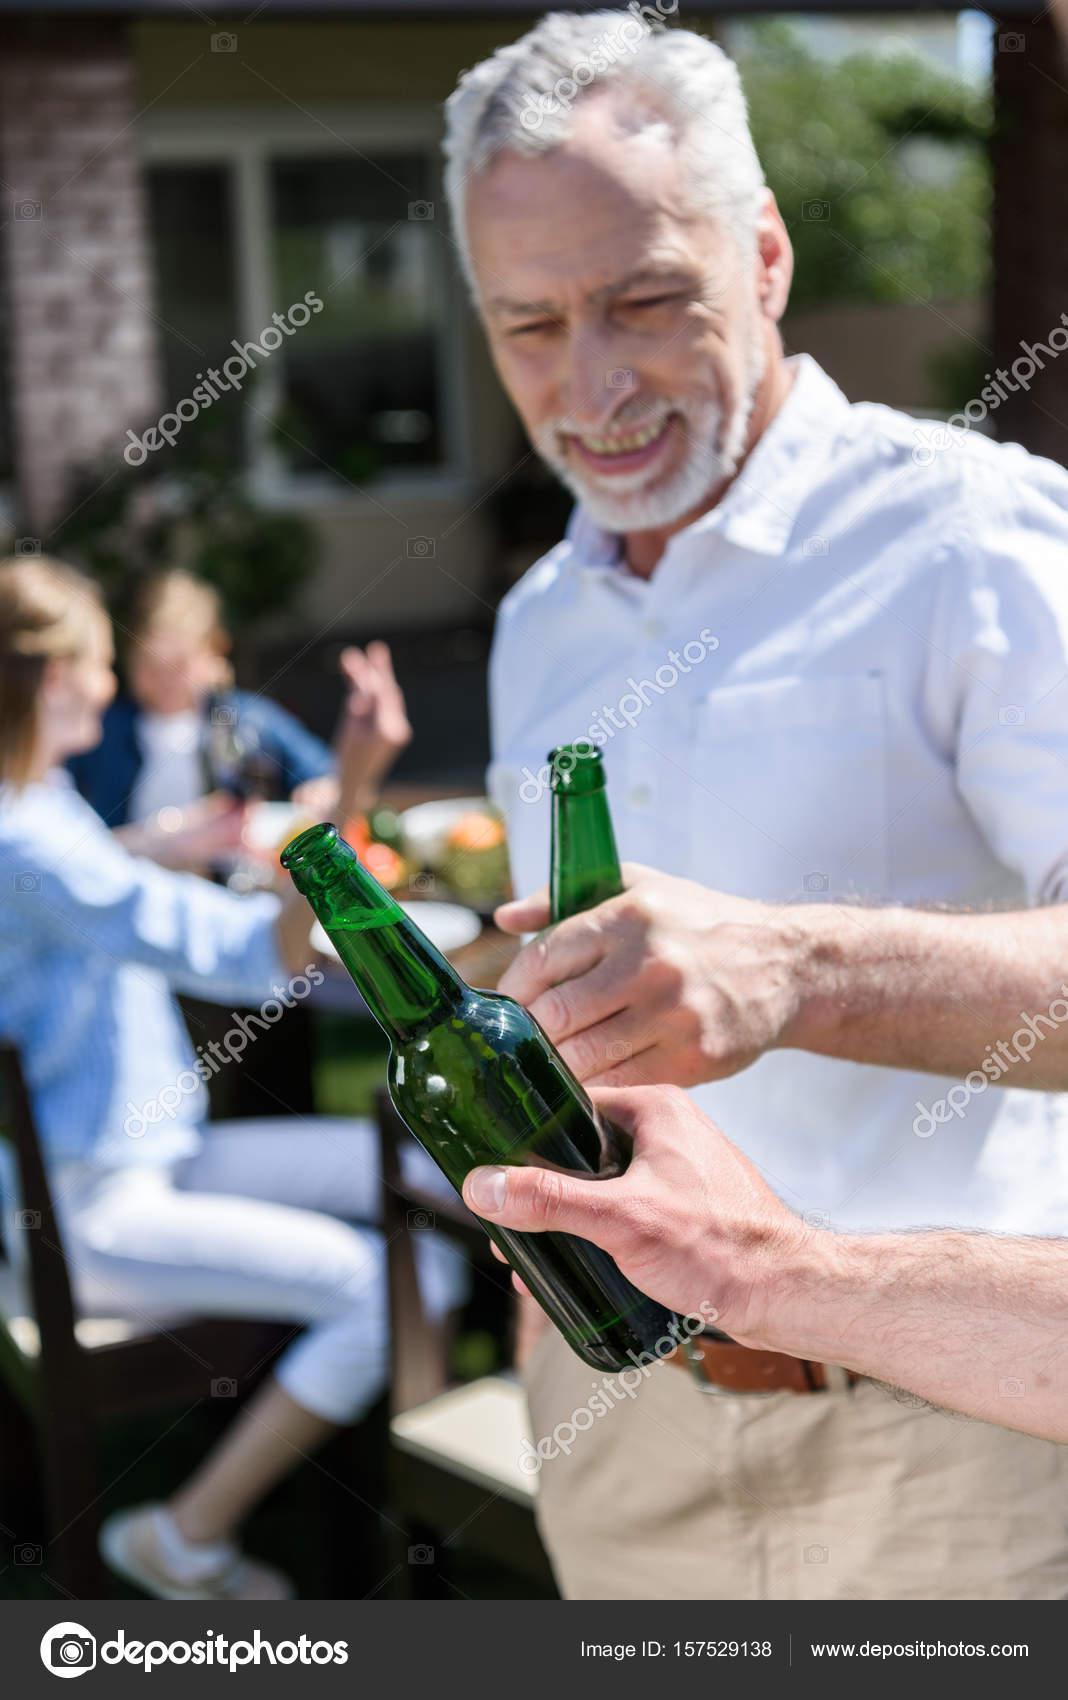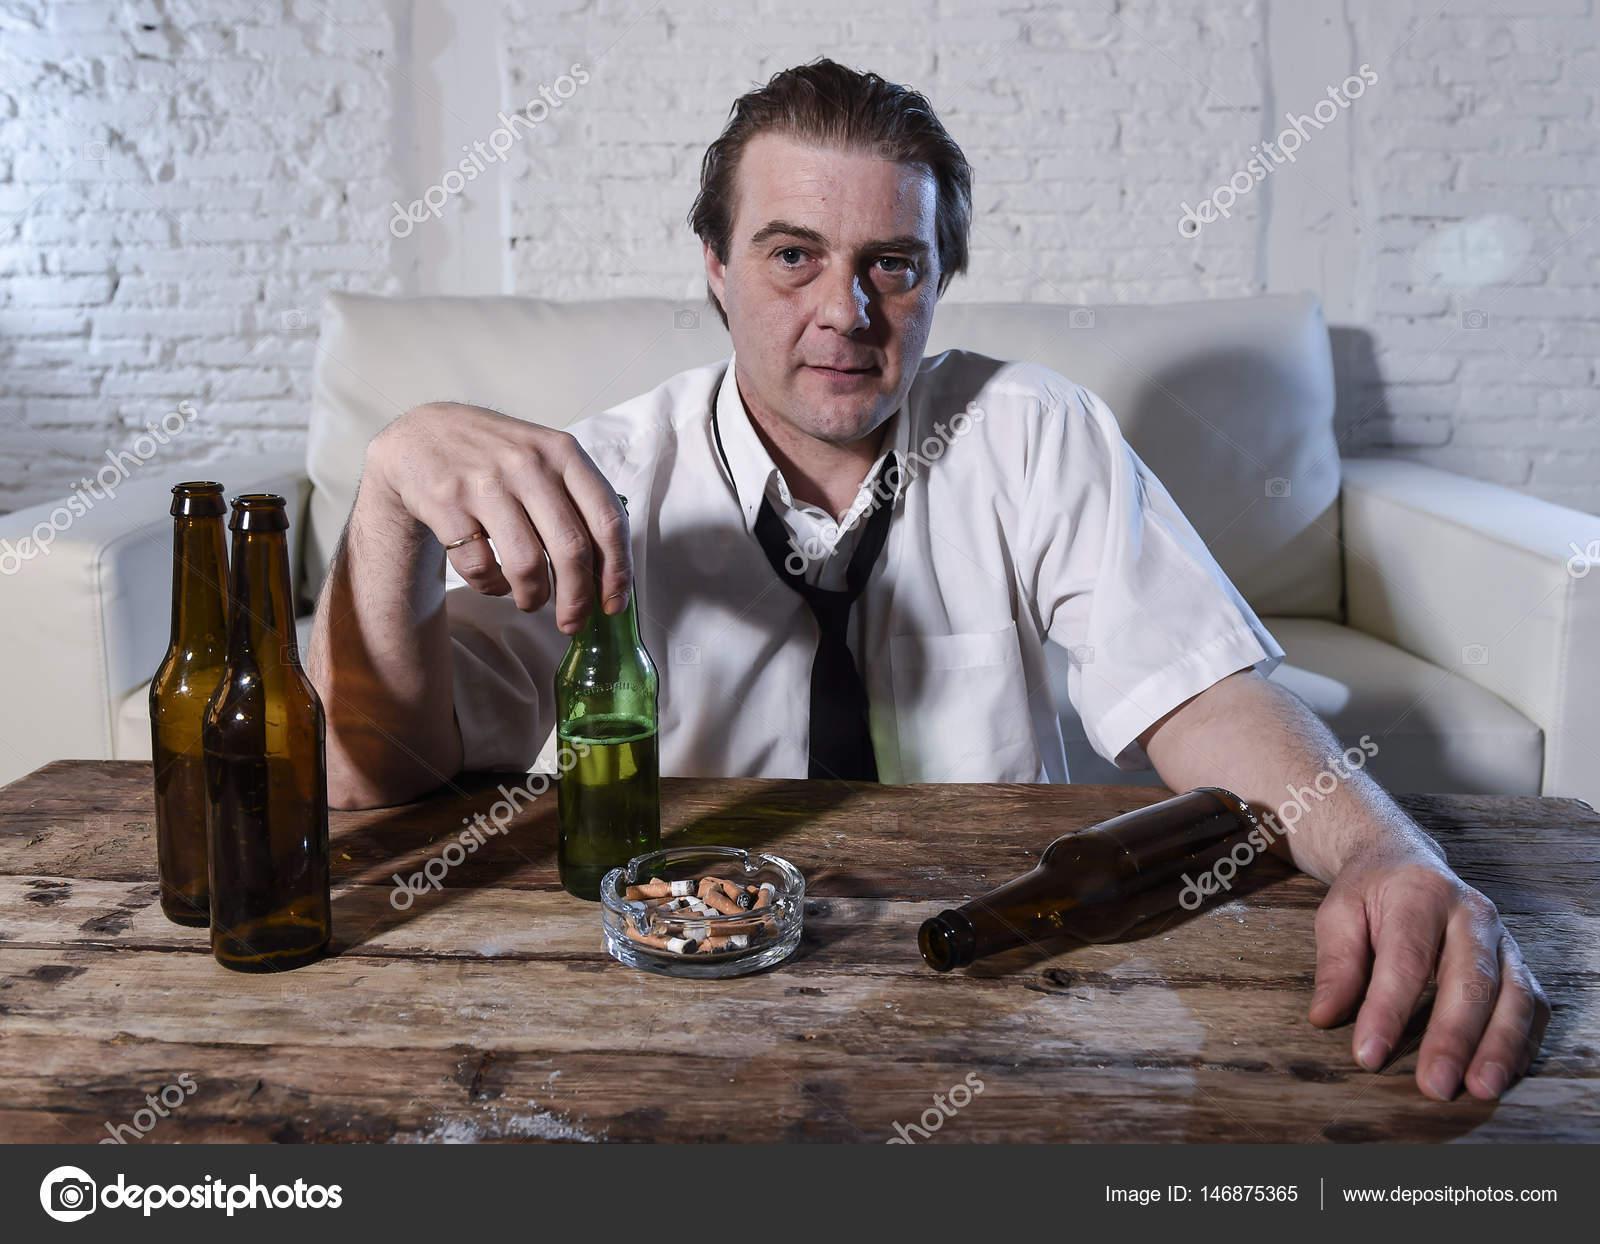The first image is the image on the left, the second image is the image on the right. For the images displayed, is the sentence "An adult is drinking a beer with the bottle touching their mouth." factually correct? Answer yes or no. No. The first image is the image on the left, the second image is the image on the right. Considering the images on both sides, is "Three hands are touching three bottles." valid? Answer yes or no. Yes. 